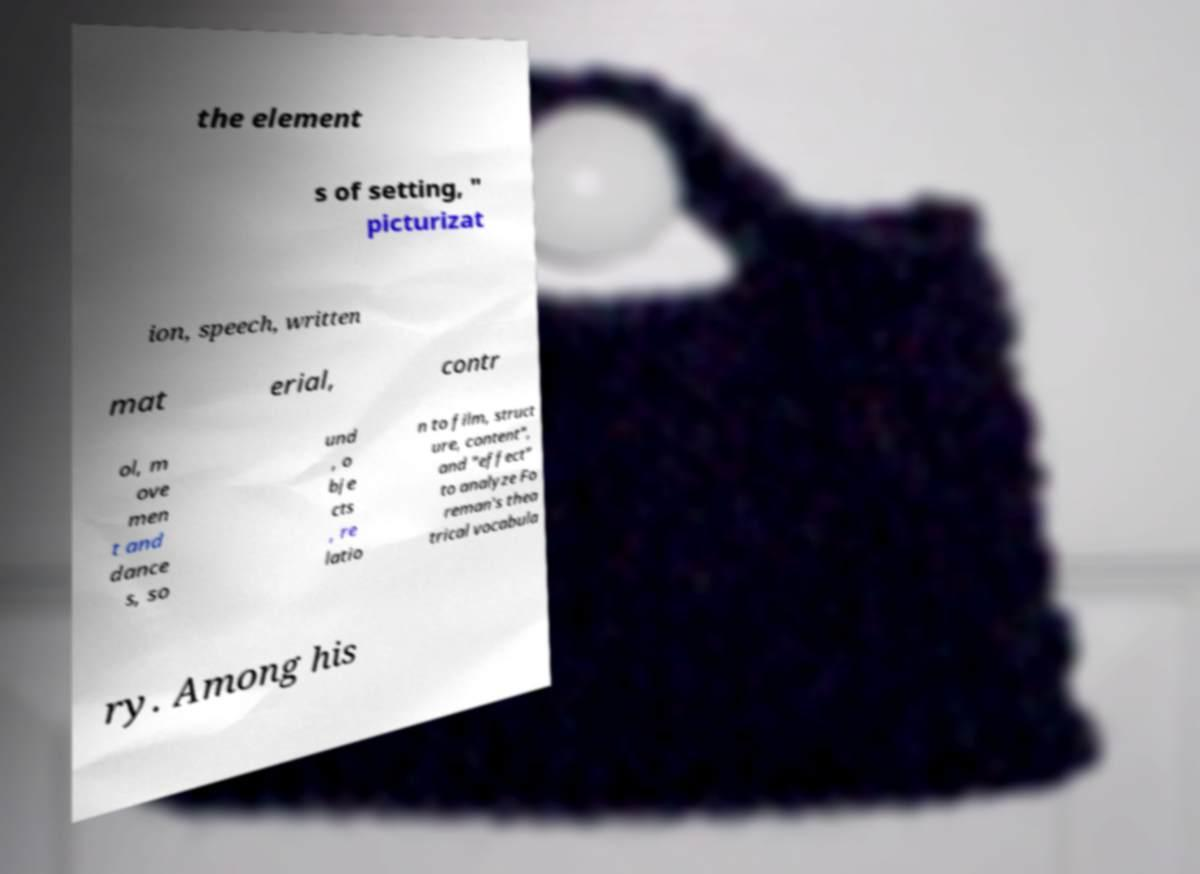There's text embedded in this image that I need extracted. Can you transcribe it verbatim? the element s of setting, " picturizat ion, speech, written mat erial, contr ol, m ove men t and dance s, so und , o bje cts , re latio n to film, struct ure, content", and "effect" to analyze Fo reman's thea trical vocabula ry. Among his 